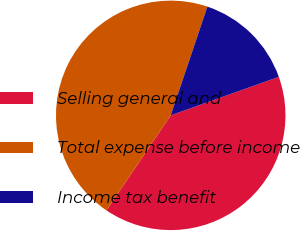Convert chart to OTSL. <chart><loc_0><loc_0><loc_500><loc_500><pie_chart><fcel>Selling general and<fcel>Total expense before income<fcel>Income tax benefit<nl><fcel>39.91%<fcel>45.71%<fcel>14.38%<nl></chart> 